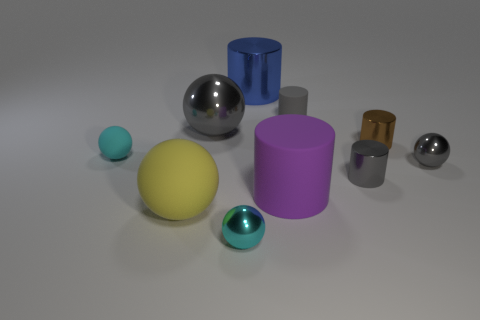Subtract all small balls. How many balls are left? 2 Subtract all cyan spheres. How many spheres are left? 3 Subtract 2 balls. How many balls are left? 3 Add 8 gray matte things. How many gray matte things are left? 9 Add 7 small brown cylinders. How many small brown cylinders exist? 8 Subtract 2 cyan balls. How many objects are left? 8 Subtract all cyan spheres. Subtract all blue cylinders. How many spheres are left? 3 Subtract all yellow cylinders. How many yellow spheres are left? 1 Subtract all large metal things. Subtract all purple matte cubes. How many objects are left? 8 